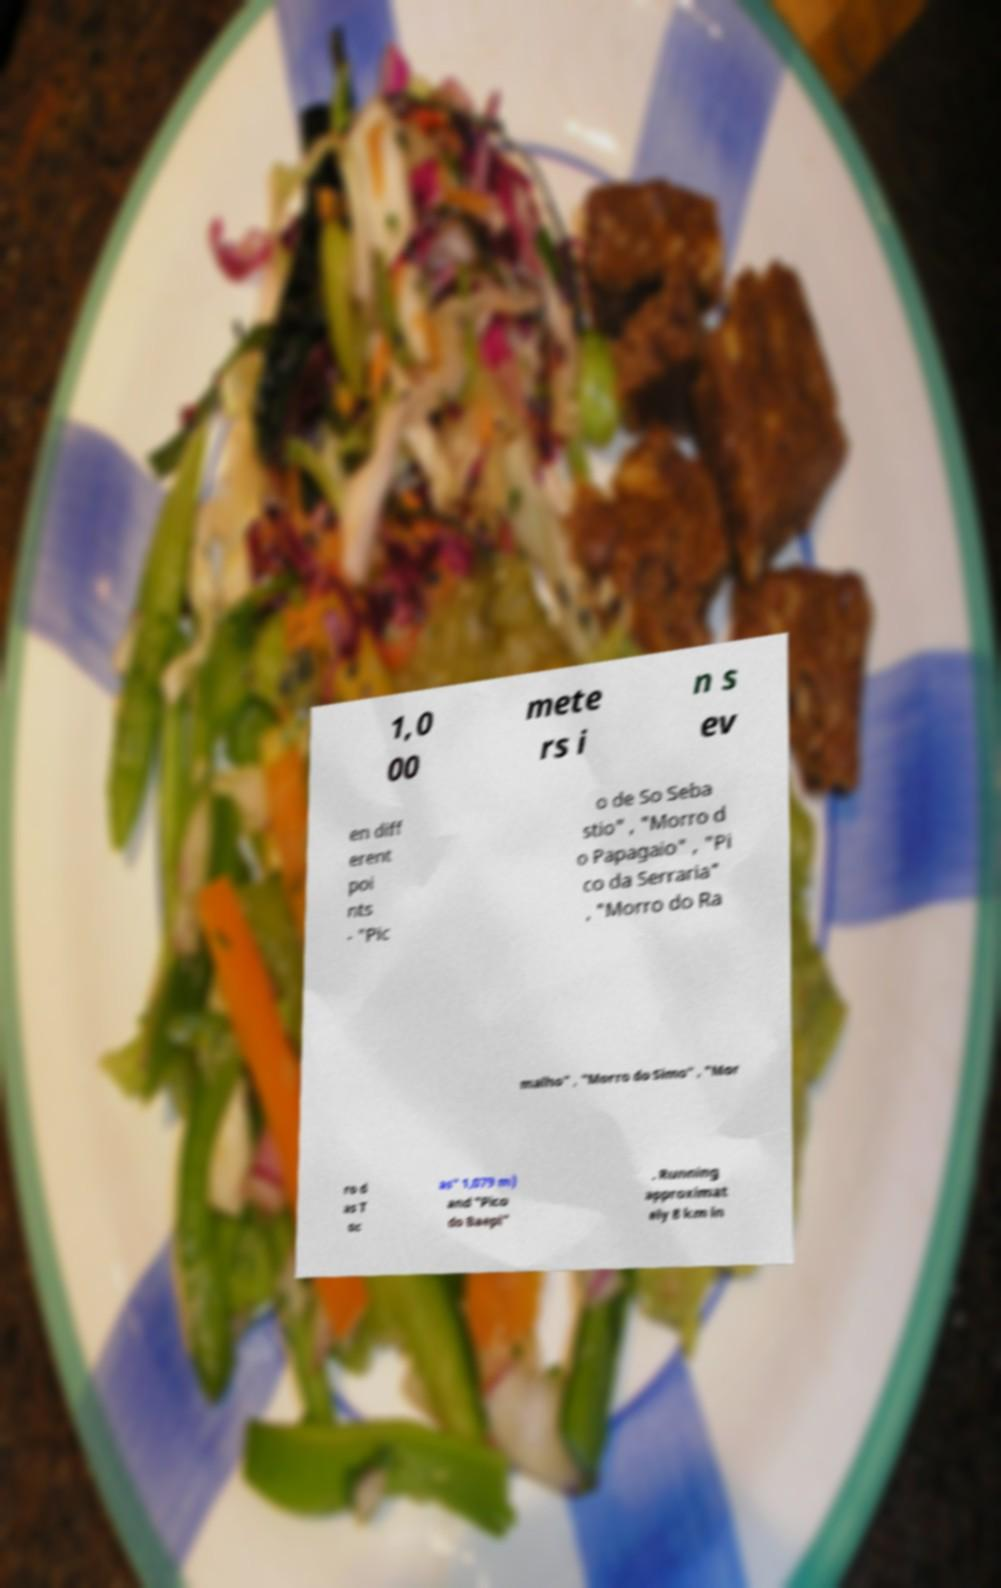Can you accurately transcribe the text from the provided image for me? 1,0 00 mete rs i n s ev en diff erent poi nts - "Pic o de So Seba stio" , "Morro d o Papagaio" , "Pi co da Serraria" , "Morro do Ra malho" , "Morro do Simo" , "Mor ro d as T oc as" 1,079 m) and "Pico do Baepi" . Running approximat ely 8 km in 